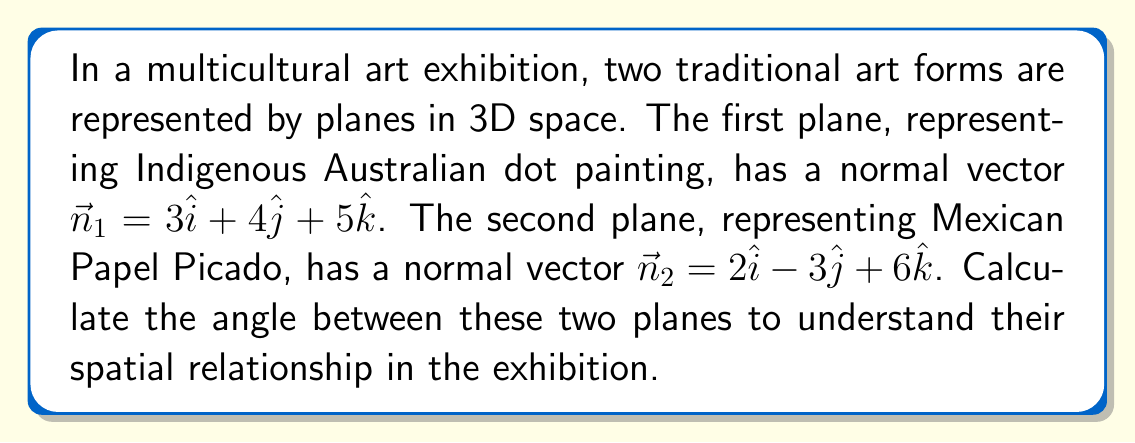What is the answer to this math problem? To find the angle between two planes, we can use the angle between their normal vectors. The formula for the angle $\theta$ between two vectors $\vec{a}$ and $\vec{b}$ is:

$$\cos \theta = \frac{\vec{a} \cdot \vec{b}}{|\vec{a}||\vec{b}|}$$

Step 1: Calculate the dot product of the normal vectors.
$\vec{n}_1 \cdot \vec{n}_2 = (3)(2) + (4)(-3) + (5)(6) = 6 - 12 + 30 = 24$

Step 2: Calculate the magnitudes of the normal vectors.
$|\vec{n}_1| = \sqrt{3^2 + 4^2 + 5^2} = \sqrt{9 + 16 + 25} = \sqrt{50}$
$|\vec{n}_2| = \sqrt{2^2 + (-3)^2 + 6^2} = \sqrt{4 + 9 + 36} = \sqrt{49} = 7$

Step 3: Apply the formula.
$$\cos \theta = \frac{24}{\sqrt{50} \cdot 7}$$

Step 4: Simplify the fraction.
$$\cos \theta = \frac{24}{7\sqrt{50}} = \frac{24}{7\sqrt{25 \cdot 2}} = \frac{24}{35\sqrt{2}}$$

Step 5: Take the inverse cosine (arccos) of both sides.
$$\theta = \arccos\left(\frac{24}{35\sqrt{2}}\right)$$

Step 6: Calculate the result (approximately).
$\theta \approx 1.0996$ radians or $63.0265°$
Answer: $\arccos\left(\frac{24}{35\sqrt{2}}\right)$ radians or approximately $63.03°$ 